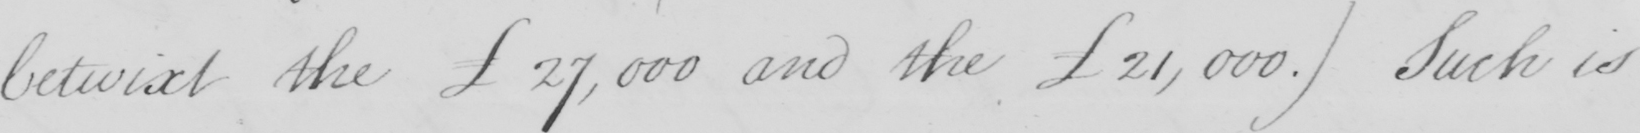What is written in this line of handwriting? betwixt the  £27,000 and the £21,000 . )  Such is 